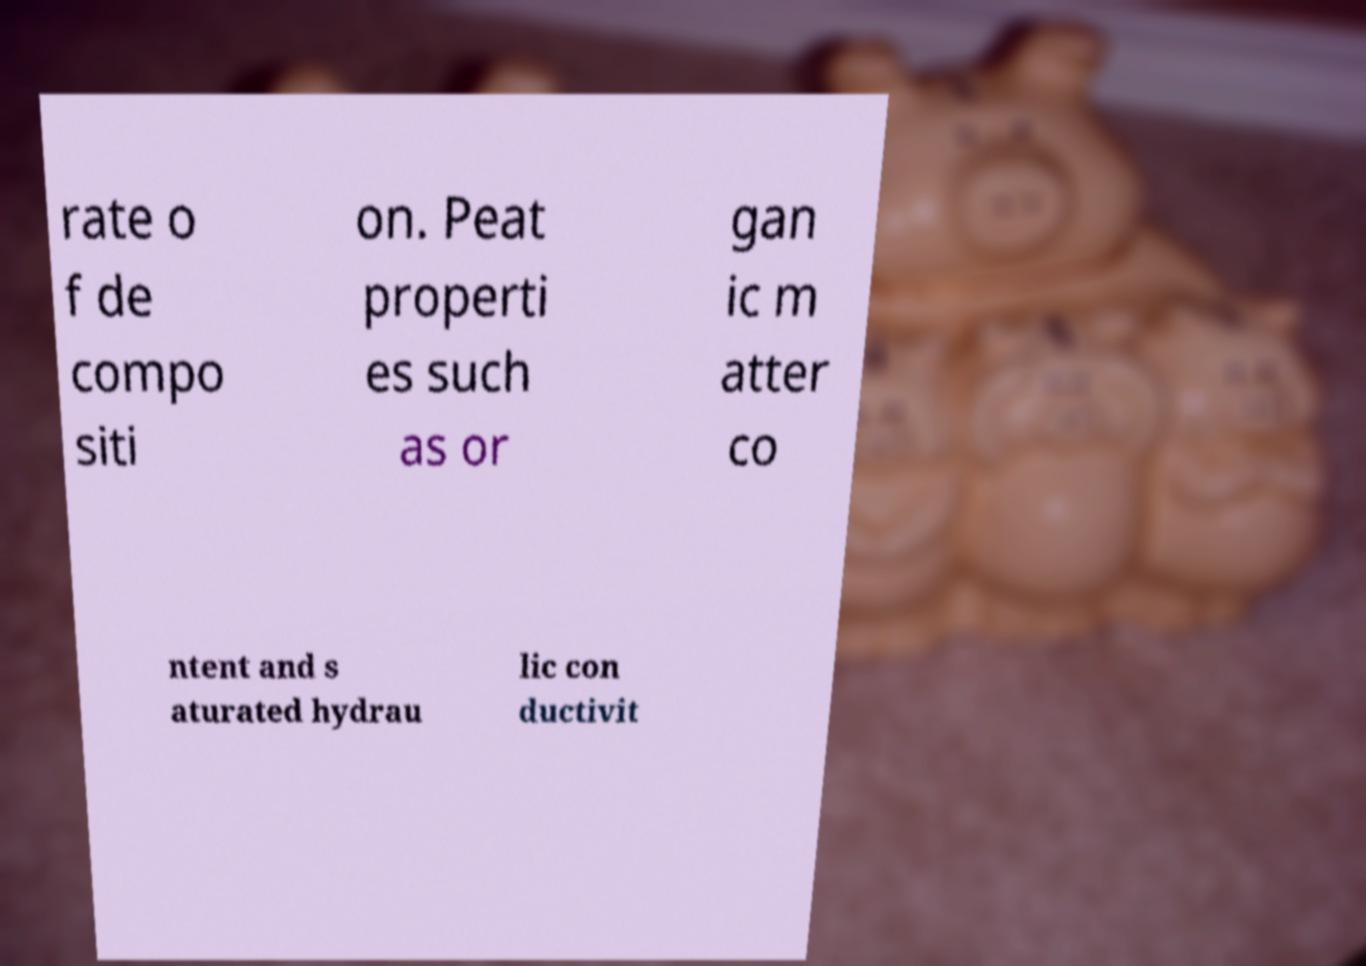Could you extract and type out the text from this image? rate o f de compo siti on. Peat properti es such as or gan ic m atter co ntent and s aturated hydrau lic con ductivit 